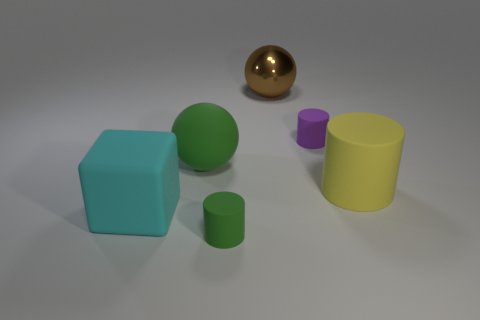Which objects in the image could potentially float on water? Based on the image, if we consider the typical materials of the objects depicted, the green ball and the golden sphere have shapes and can be made of materials that allow them to float. However, without specific material properties, it is purely speculative. 